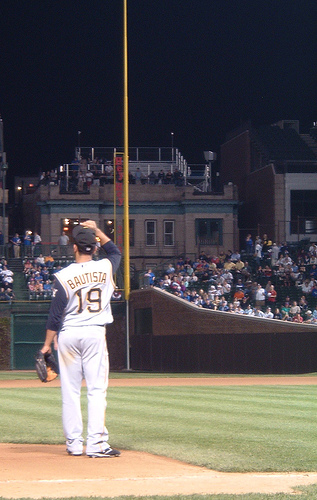Each image has something going on. Carefully analyze the image and generate 5 captions for each image. Caption 1: A solitary figure on the field, "BAUTISTA" stands ready as the game unfolds under the bright lights of the stadium.
Caption 2: Number 19 gazes into the diamond, the calm in the eye of the storm of cheers and anticipation from the watching crowd.
Caption 3: As night envelops the city, the game presses on, a player clad in gray and blue holds vigil by the foul line.
Caption 4: "BAUTISTA" at the ready, a testament to the focus and determination etched into the fabric of America's favorite pastime.
Caption 5: Amidst a sea of spectators, a single player commands the field, poised for action as the next play waits in the wings. 